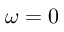<formula> <loc_0><loc_0><loc_500><loc_500>\omega = 0</formula> 